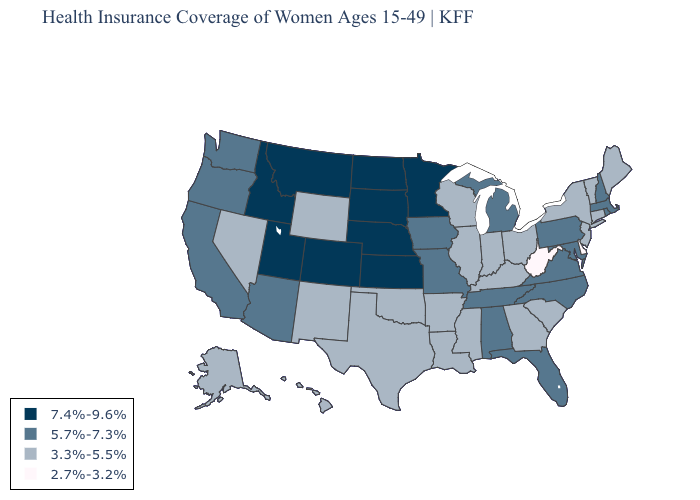Name the states that have a value in the range 5.7%-7.3%?
Keep it brief. Alabama, Arizona, California, Florida, Iowa, Maryland, Massachusetts, Michigan, Missouri, New Hampshire, North Carolina, Oregon, Pennsylvania, Rhode Island, Tennessee, Virginia, Washington. Name the states that have a value in the range 7.4%-9.6%?
Answer briefly. Colorado, Idaho, Kansas, Minnesota, Montana, Nebraska, North Dakota, South Dakota, Utah. Does Tennessee have the same value as California?
Be succinct. Yes. Name the states that have a value in the range 5.7%-7.3%?
Give a very brief answer. Alabama, Arizona, California, Florida, Iowa, Maryland, Massachusetts, Michigan, Missouri, New Hampshire, North Carolina, Oregon, Pennsylvania, Rhode Island, Tennessee, Virginia, Washington. Among the states that border Massachusetts , which have the highest value?
Answer briefly. New Hampshire, Rhode Island. Name the states that have a value in the range 7.4%-9.6%?
Keep it brief. Colorado, Idaho, Kansas, Minnesota, Montana, Nebraska, North Dakota, South Dakota, Utah. Among the states that border Idaho , does Montana have the lowest value?
Short answer required. No. Which states hav the highest value in the MidWest?
Write a very short answer. Kansas, Minnesota, Nebraska, North Dakota, South Dakota. What is the highest value in states that border Alabama?
Give a very brief answer. 5.7%-7.3%. Name the states that have a value in the range 3.3%-5.5%?
Short answer required. Alaska, Arkansas, Connecticut, Georgia, Hawaii, Illinois, Indiana, Kentucky, Louisiana, Maine, Mississippi, Nevada, New Jersey, New Mexico, New York, Ohio, Oklahoma, South Carolina, Texas, Vermont, Wisconsin, Wyoming. Name the states that have a value in the range 2.7%-3.2%?
Write a very short answer. Delaware, West Virginia. Among the states that border Virginia , does Kentucky have the highest value?
Answer briefly. No. Name the states that have a value in the range 7.4%-9.6%?
Give a very brief answer. Colorado, Idaho, Kansas, Minnesota, Montana, Nebraska, North Dakota, South Dakota, Utah. Among the states that border Michigan , which have the highest value?
Write a very short answer. Indiana, Ohio, Wisconsin. Does Alabama have the lowest value in the South?
Quick response, please. No. 